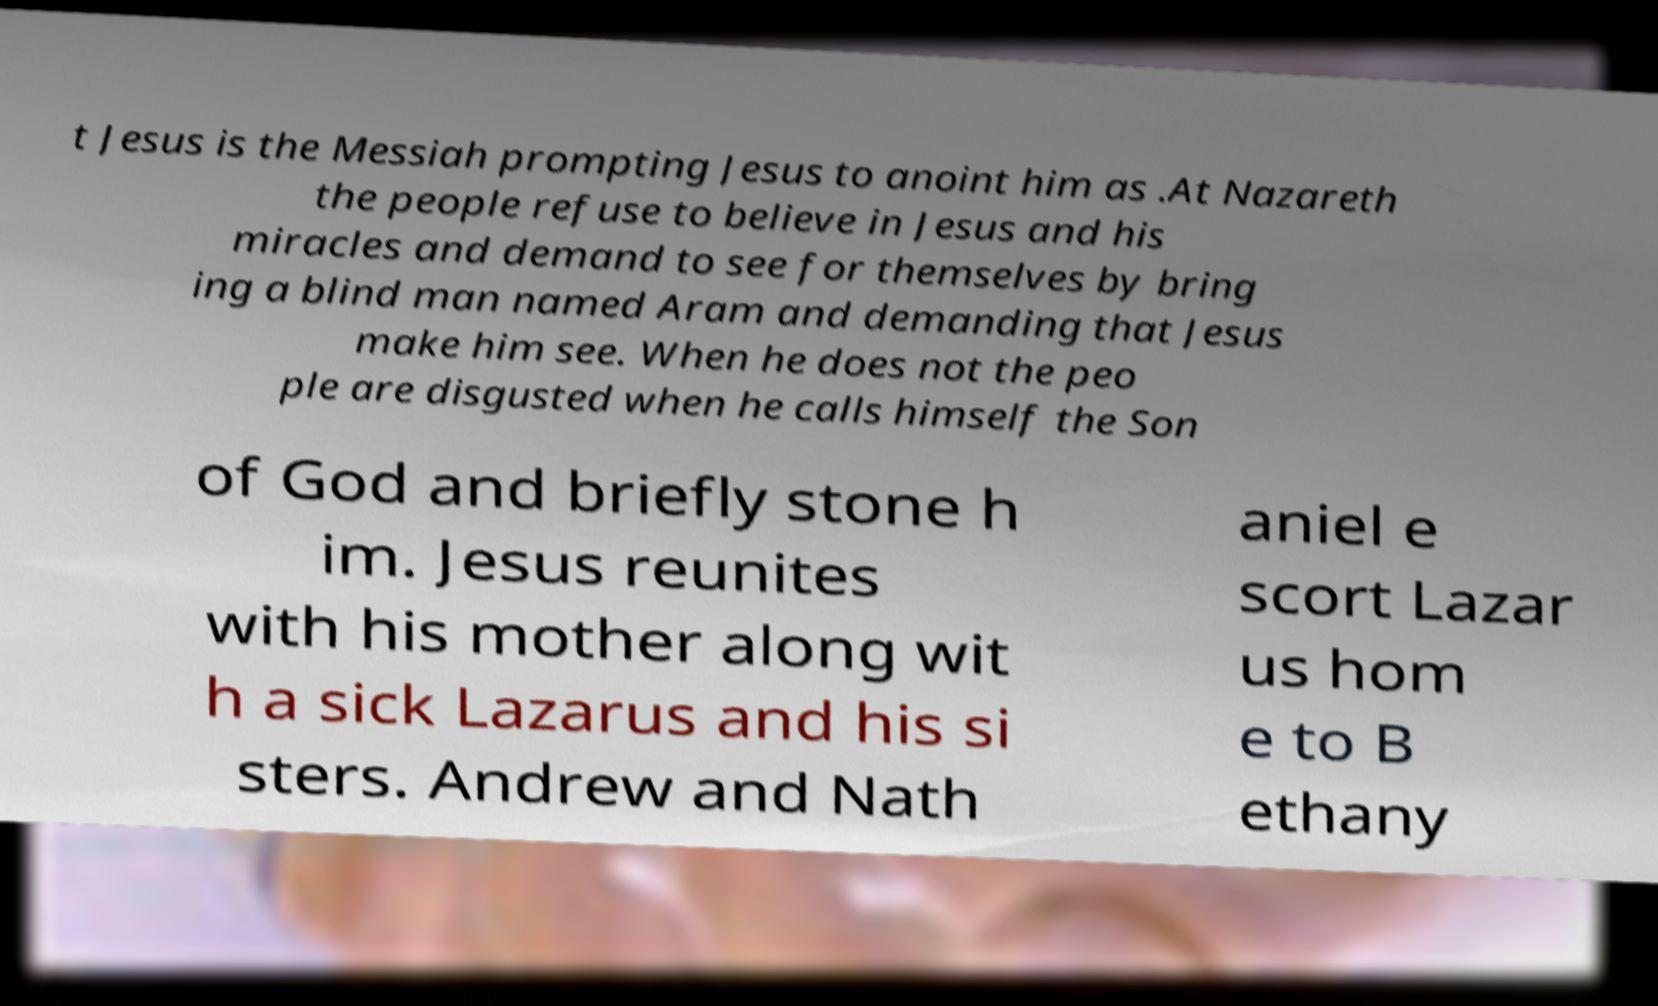Please read and relay the text visible in this image. What does it say? t Jesus is the Messiah prompting Jesus to anoint him as .At Nazareth the people refuse to believe in Jesus and his miracles and demand to see for themselves by bring ing a blind man named Aram and demanding that Jesus make him see. When he does not the peo ple are disgusted when he calls himself the Son of God and briefly stone h im. Jesus reunites with his mother along wit h a sick Lazarus and his si sters. Andrew and Nath aniel e scort Lazar us hom e to B ethany 